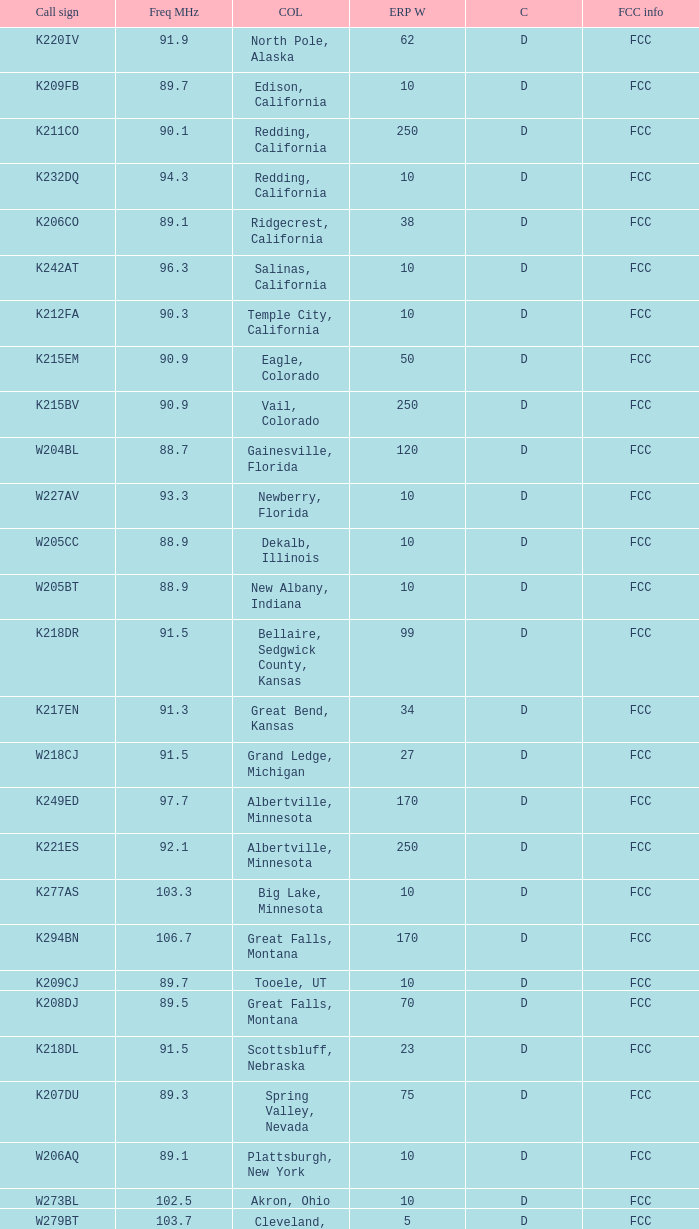What is the class of the translator with 10 ERP W and a call sign of w273bl? D. 